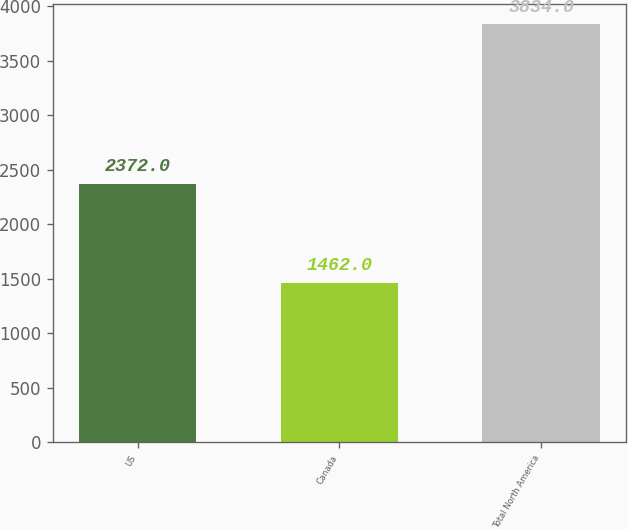Convert chart. <chart><loc_0><loc_0><loc_500><loc_500><bar_chart><fcel>US<fcel>Canada<fcel>Total North America<nl><fcel>2372<fcel>1462<fcel>3834<nl></chart> 